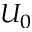<formula> <loc_0><loc_0><loc_500><loc_500>U _ { 0 }</formula> 